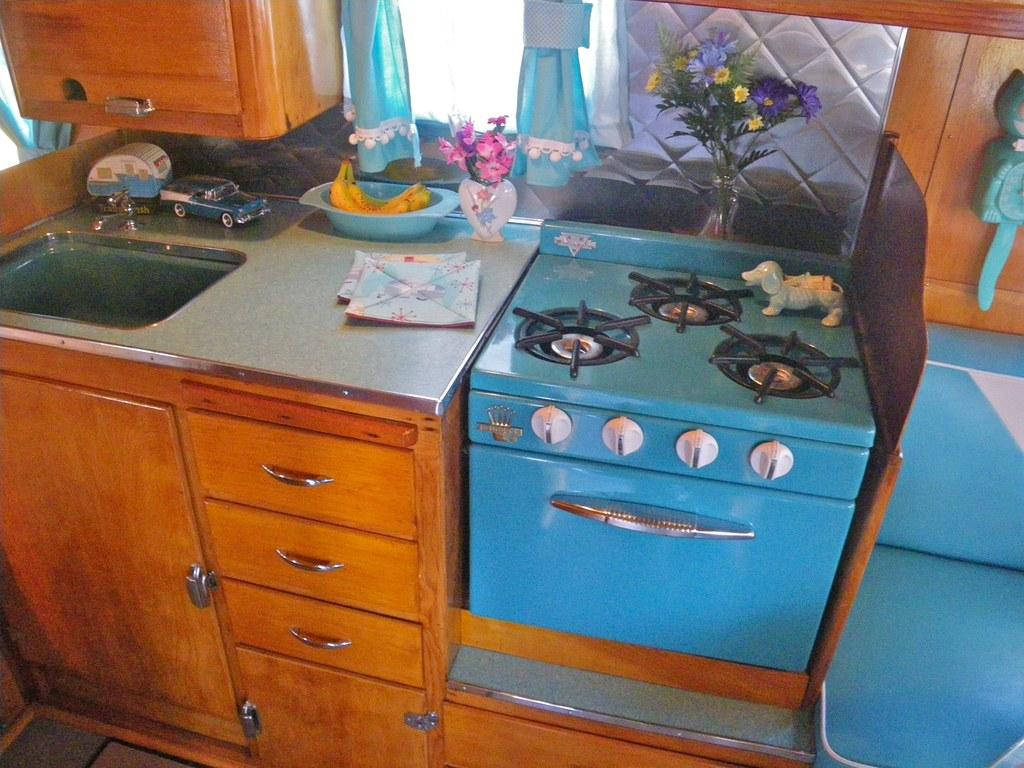What type of furniture is present in the image? There are cupboards in the image. What can be found in the kitchen area of the image? There is a sink and a tap in the image. What items are visible that might be used for play? There are toys in the image. What type of fruit can be seen in the image? There are bananas in the image. What type of decorative items are present in the image? There are flowers and vases in the image. What type of window treatment is present in the image? There are curtains in the image. What type of cooking appliance is present in the image? There is a stove in the image. What other objects can be seen in the image? There are other objects in the image, but their specific details are not mentioned in the provided facts. Can you hear the yak sneezing in the image? There is no yak present in the image, so it cannot be heard sneezing. What type of horn is visible on the stove in the image? There is no horn present on the stove in the image. 